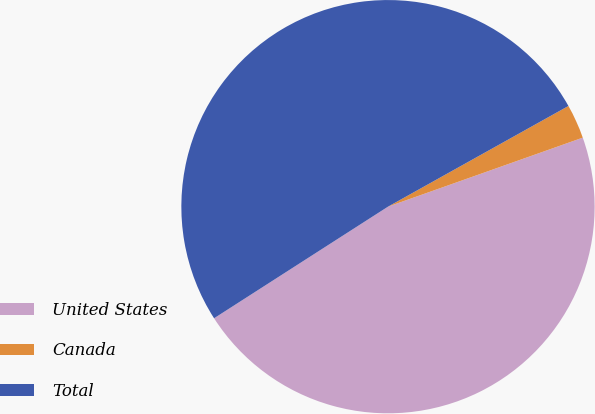Convert chart to OTSL. <chart><loc_0><loc_0><loc_500><loc_500><pie_chart><fcel>United States<fcel>Canada<fcel>Total<nl><fcel>46.34%<fcel>2.68%<fcel>50.98%<nl></chart> 